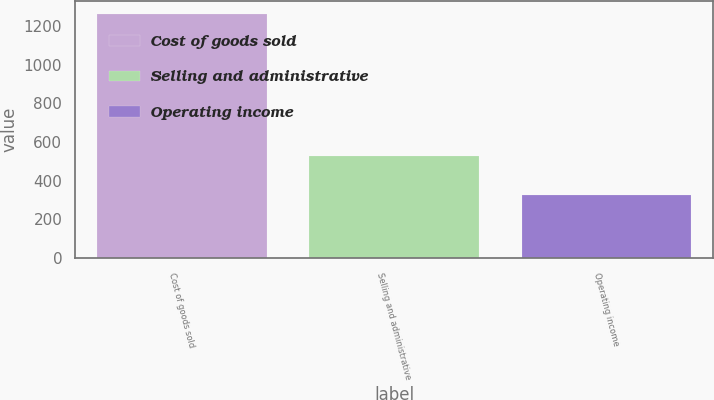Convert chart. <chart><loc_0><loc_0><loc_500><loc_500><bar_chart><fcel>Cost of goods sold<fcel>Selling and administrative<fcel>Operating income<nl><fcel>1264.6<fcel>527.4<fcel>326.3<nl></chart> 